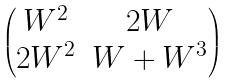Convert formula to latex. <formula><loc_0><loc_0><loc_500><loc_500>\begin{pmatrix} W ^ { 2 } & 2 W \\ 2 W ^ { 2 } & W + W ^ { 3 } \end{pmatrix}</formula> 